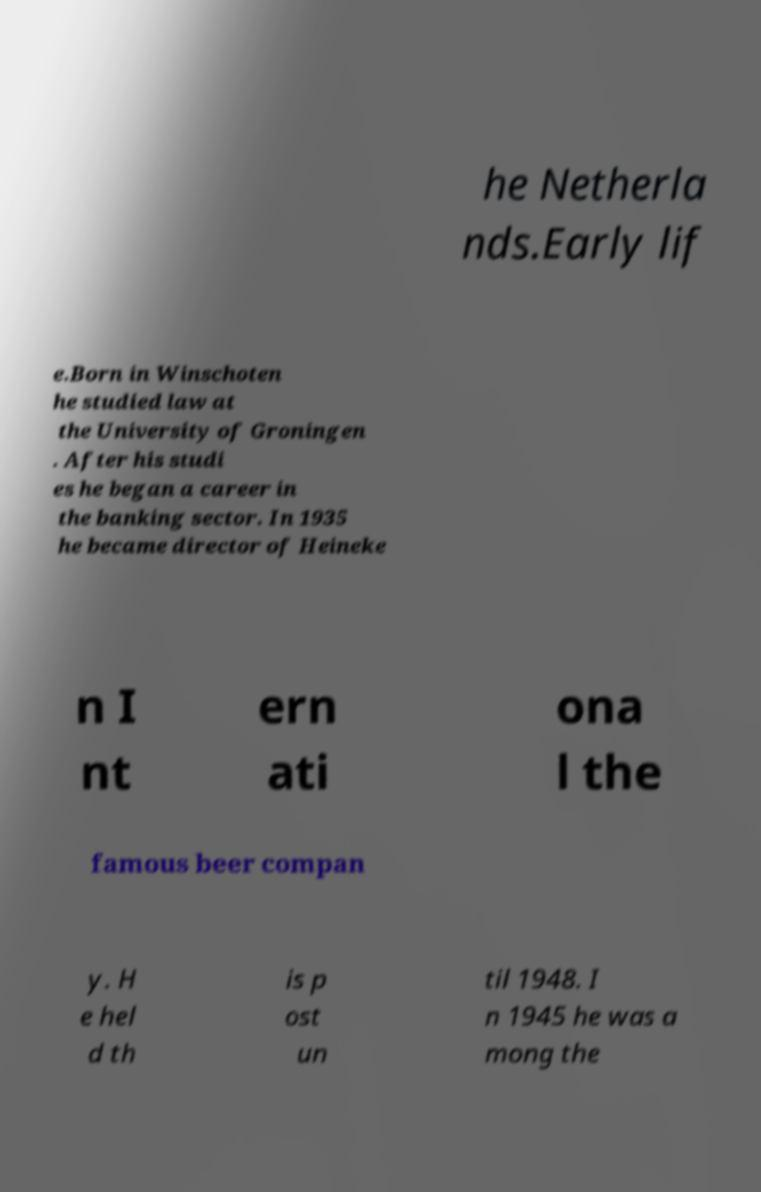I need the written content from this picture converted into text. Can you do that? he Netherla nds.Early lif e.Born in Winschoten he studied law at the University of Groningen . After his studi es he began a career in the banking sector. In 1935 he became director of Heineke n I nt ern ati ona l the famous beer compan y. H e hel d th is p ost un til 1948. I n 1945 he was a mong the 